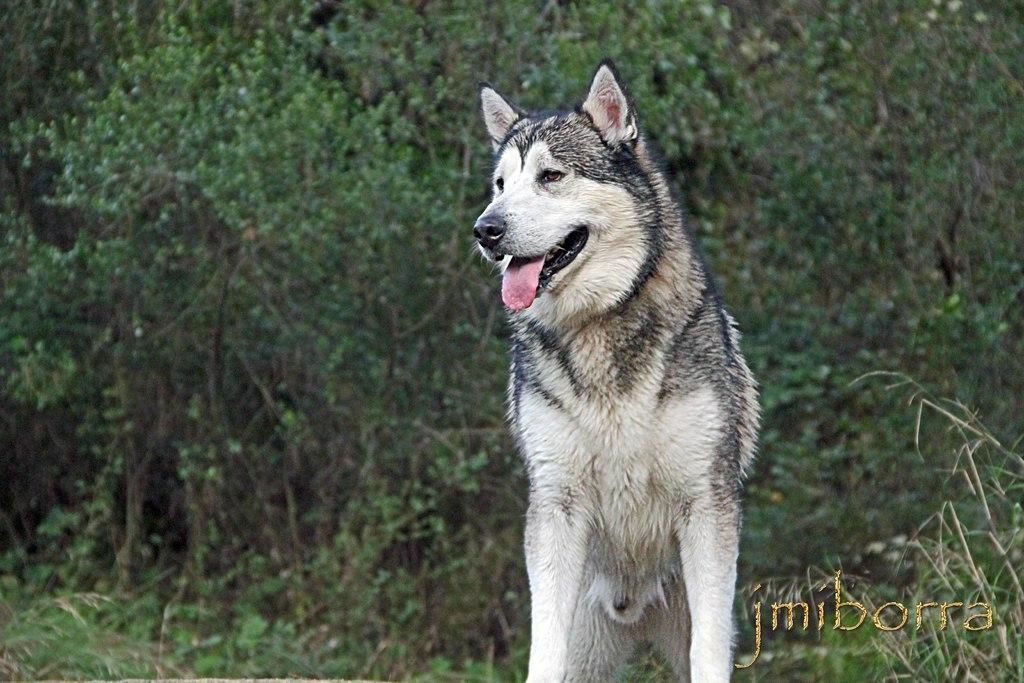What animal is in the foreground of the image? There is a wolf in the foreground of the image. What can be seen in the background of the image? There are trees and plants in the background of the image. Is there any text present in the image? Yes, there is some text in the right bottom corner of the image. What type of twig is the police officer using to manage the wolf in the image? There is no police officer, twig, or management of the wolf in the image; it simply features a wolf in the foreground and trees and plants in the background. 